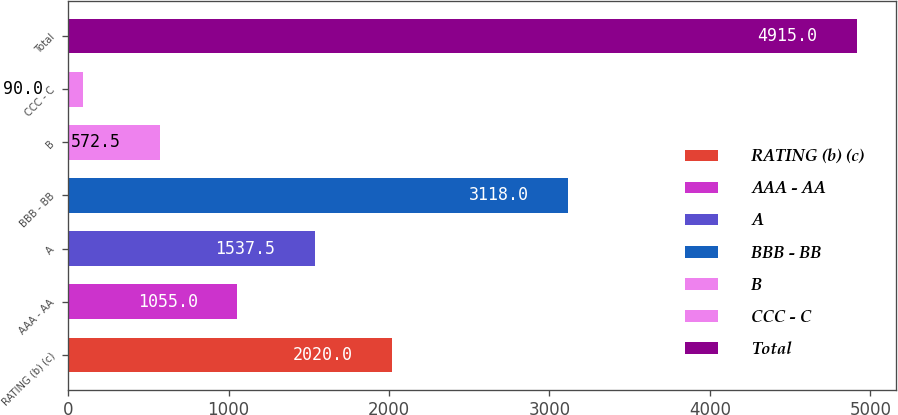<chart> <loc_0><loc_0><loc_500><loc_500><bar_chart><fcel>RATING (b) (c)<fcel>AAA - AA<fcel>A<fcel>BBB - BB<fcel>B<fcel>CCC - C<fcel>Total<nl><fcel>2020<fcel>1055<fcel>1537.5<fcel>3118<fcel>572.5<fcel>90<fcel>4915<nl></chart> 